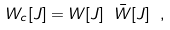Convert formula to latex. <formula><loc_0><loc_0><loc_500><loc_500>W _ { c } [ J ] = W [ J ] \ { \bar { W } } [ J ] \ ,</formula> 